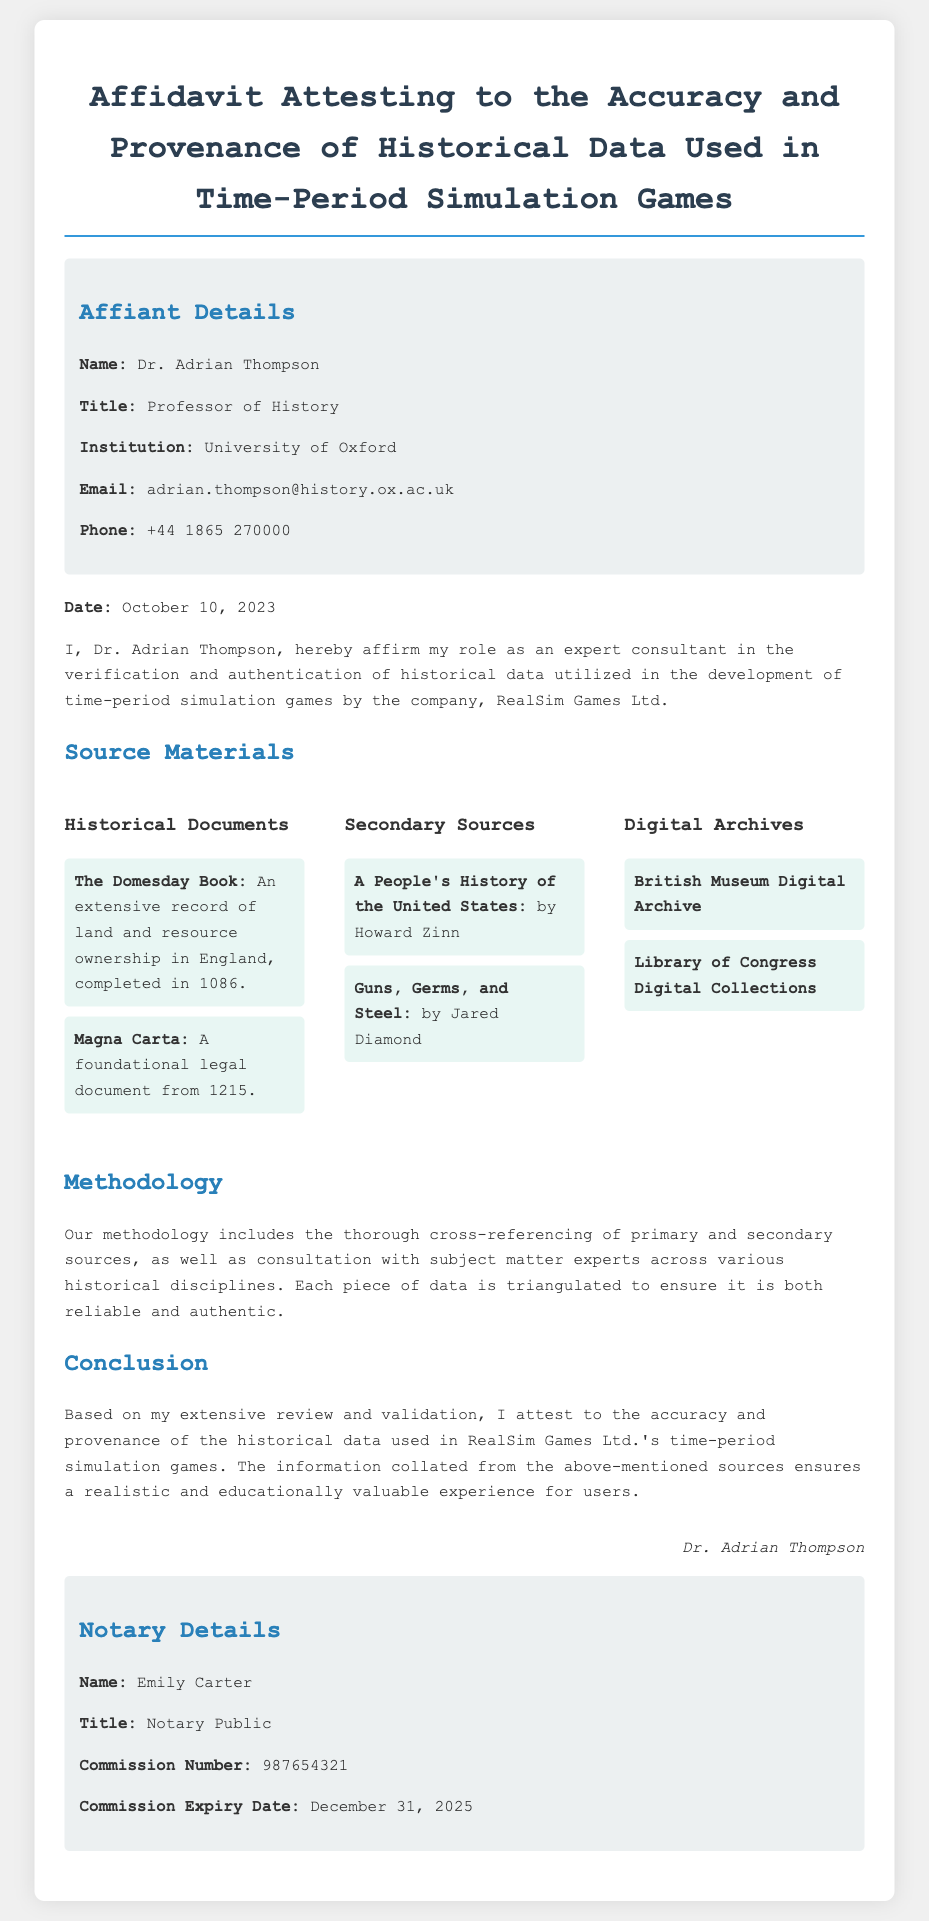What is the name of the affiant? The name of the affiant is provided in the document under "Affiant Details."
Answer: Dr. Adrian Thompson What is the title of the affiant? The title of the affiant is mentioned in the "Affiant Details" section of the document.
Answer: Professor of History What is the date of the affidavit? The date is explicitly stated within the document.
Answer: October 10, 2023 What is the commission number of the notary? The commission number is specified in the "Notary Details" section.
Answer: 987654321 Which institution is mentioned in the affiant's details? The institution is provided as part of the affiant's details in the document.
Answer: University of Oxford What are the names of two historical documents cited? The document lists specific historical documents in the "Source Materials" section.
Answer: The Domesday Book, Magna Carta What methodology is mentioned for verifying historical data? The methodology section describes the process used for validation and verification.
Answer: Cross-referencing What is the conclusion provided by the affiant? The affiant's conclusion summarizes the validation of the historical data.
Answer: Attest to the accuracy and provenance What are the two secondary sources listed? The document specifies certain secondary sources within the "Source Materials" section.
Answer: A People's History of the United States, Guns, Germs, and Steel Who is the notary public named in the document? The name of the notary public is found in the "Notary Details" section.
Answer: Emily Carter 